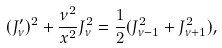<formula> <loc_0><loc_0><loc_500><loc_500>( J _ { \nu } ^ { \prime } ) ^ { 2 } + \frac { \nu ^ { 2 } } { x ^ { 2 } } J _ { \nu } ^ { 2 } = \frac { 1 } { 2 } ( J _ { \nu - 1 } ^ { 2 } + J _ { \nu + 1 } ^ { 2 } ) ,</formula> 